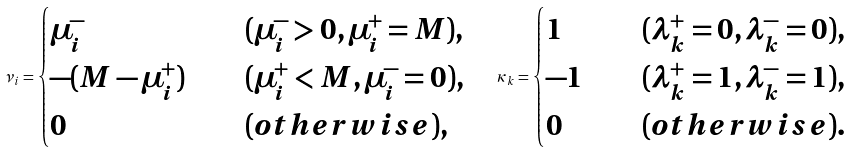<formula> <loc_0><loc_0><loc_500><loc_500>\nu _ { i } = \begin{cases} \mu _ { i } ^ { - } \quad & ( \mu _ { i } ^ { - } > 0 , \mu _ { i } ^ { + } = M ) , \\ - ( M - \mu _ { i } ^ { + } ) \quad & ( \mu _ { i } ^ { + } < M , \mu _ { i } ^ { - } = 0 ) , \\ 0 \quad & ( o t h e r w i s e ) , \end{cases} \quad \kappa _ { k } = \begin{cases} 1 \quad & ( \lambda _ { k } ^ { + } = 0 , \lambda _ { k } ^ { - } = 0 ) , \\ - 1 \quad & ( \lambda _ { k } ^ { + } = 1 , \lambda _ { k } ^ { - } = 1 ) , \\ 0 \quad & ( o t h e r w i s e ) . \end{cases}</formula> 